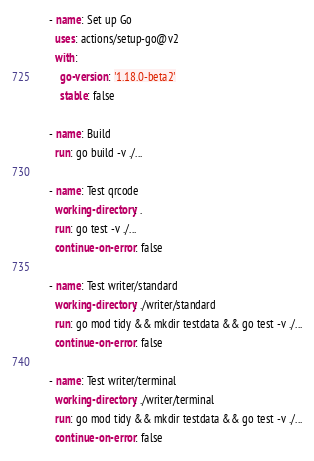<code> <loc_0><loc_0><loc_500><loc_500><_YAML_>    - name: Set up Go
      uses: actions/setup-go@v2
      with:
        go-version: '1.18.0-beta2'
        stable: false

    - name: Build
      run: go build -v ./...

    - name: Test qrcode
      working-directory: .
      run: go test -v ./...
      continue-on-error: false

    - name: Test writer/standard
      working-directory: ./writer/standard
      run: go mod tidy && mkdir testdata && go test -v ./...
      continue-on-error: false

    - name: Test writer/terminal
      working-directory: ./writer/terminal
      run: go mod tidy && mkdir testdata && go test -v ./...
      continue-on-error: false
</code> 